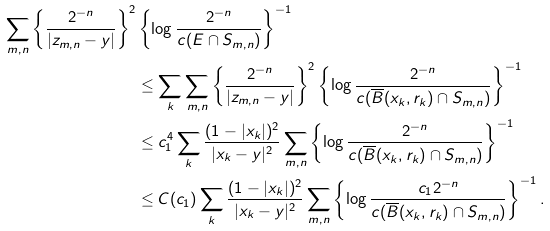<formula> <loc_0><loc_0><loc_500><loc_500>\sum _ { m , n } \left \{ \frac { 2 ^ { - n } } { | z _ { m , n } - y | } \right \} ^ { 2 } & \left \{ \log \frac { 2 ^ { - n } } { c ( E \cap S _ { m , n } ) } \right \} ^ { - 1 } \\ & \leq \sum _ { k } \sum _ { m , n } \left \{ \frac { 2 ^ { - n } } { | z _ { m , n } - y | } \right \} ^ { 2 } \left \{ \log \frac { 2 ^ { - n } } { c ( \overline { B } ( x _ { k } , r _ { k } ) \cap S _ { m , n } ) } \right \} ^ { - 1 } \\ & \leq c _ { 1 } ^ { 4 } \sum _ { k } \frac { ( 1 - | x _ { k } | ) ^ { 2 } } { | x _ { k } - y | ^ { 2 } } \sum _ { m , n } \left \{ \log \frac { 2 ^ { - n } } { c ( \overline { B } ( x _ { k } , r _ { k } ) \cap S _ { m , n } ) } \right \} ^ { - 1 } \\ & \leq C ( c _ { 1 } ) \sum _ { k } \frac { ( 1 - | x _ { k } | ) ^ { 2 } } { | x _ { k } - y | ^ { 2 } } \sum _ { m , n } \left \{ \log \frac { c _ { 1 } 2 ^ { - n } } { c ( \overline { B } ( x _ { k } , r _ { k } ) \cap S _ { m , n } ) } \right \} ^ { - 1 } .</formula> 